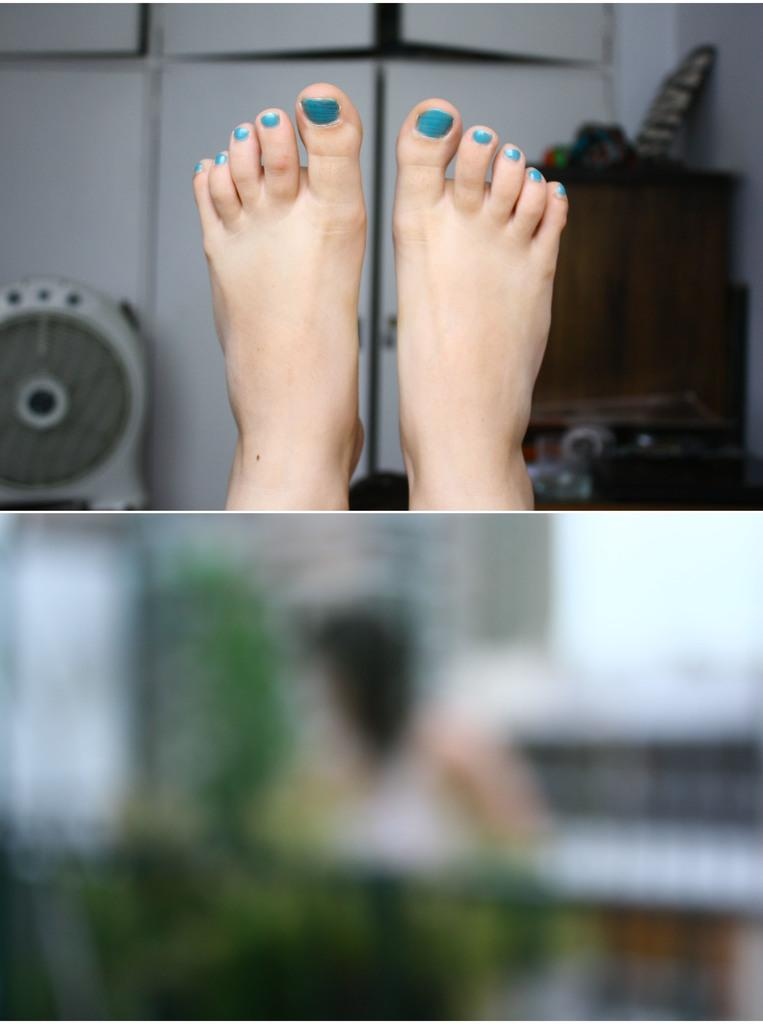What body part can be seen in the image? There are legs visible in the image. What type of structure is present in the image? There is a wall in the image. What else can be seen in the image besides the legs and wall? There are other objects visible in the image. What type of skin condition is visible on the legs in the image? There is no skin condition visible on the legs in the image; only the legs themselves are visible. 